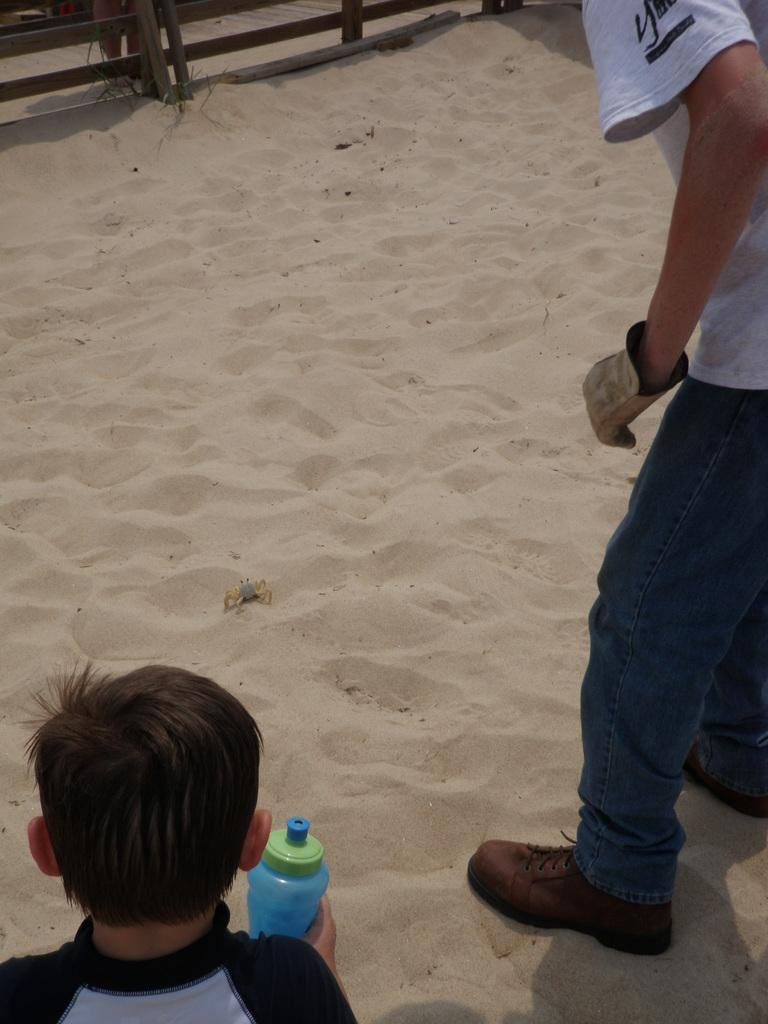How many people are in the image? There are two people in the image. Where are the people standing? The people are standing in the sand. What is the person on the right side wearing? The person on the right side is wearing a glove. What is the person on the left bottom side holding? The person on the left bottom side is holding a bottle. What color are the eyes of the person on the left side in the image? There is no information about the color of the eyes of the person on the left side in the image. 